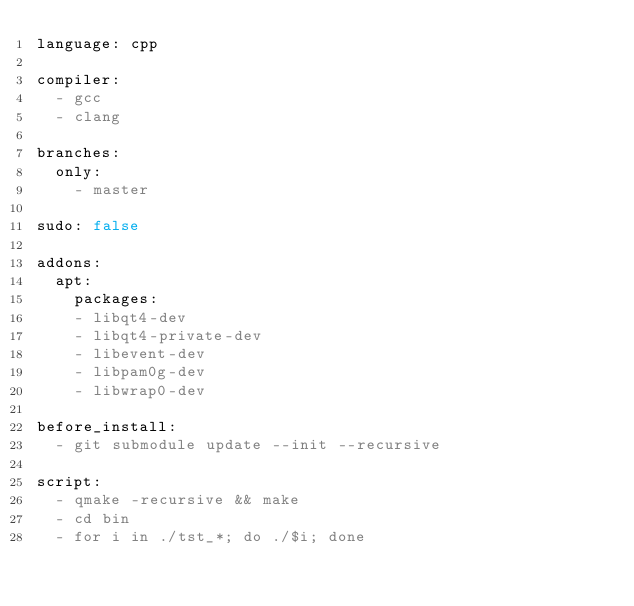<code> <loc_0><loc_0><loc_500><loc_500><_YAML_>language: cpp

compiler:
  - gcc
  - clang

branches:
  only:
    - master

sudo: false

addons:
  apt:
    packages:
    - libqt4-dev
    - libqt4-private-dev
    - libevent-dev
    - libpam0g-dev
    - libwrap0-dev

before_install:
  - git submodule update --init --recursive

script:
  - qmake -recursive && make
  - cd bin
  - for i in ./tst_*; do ./$i; done
</code> 